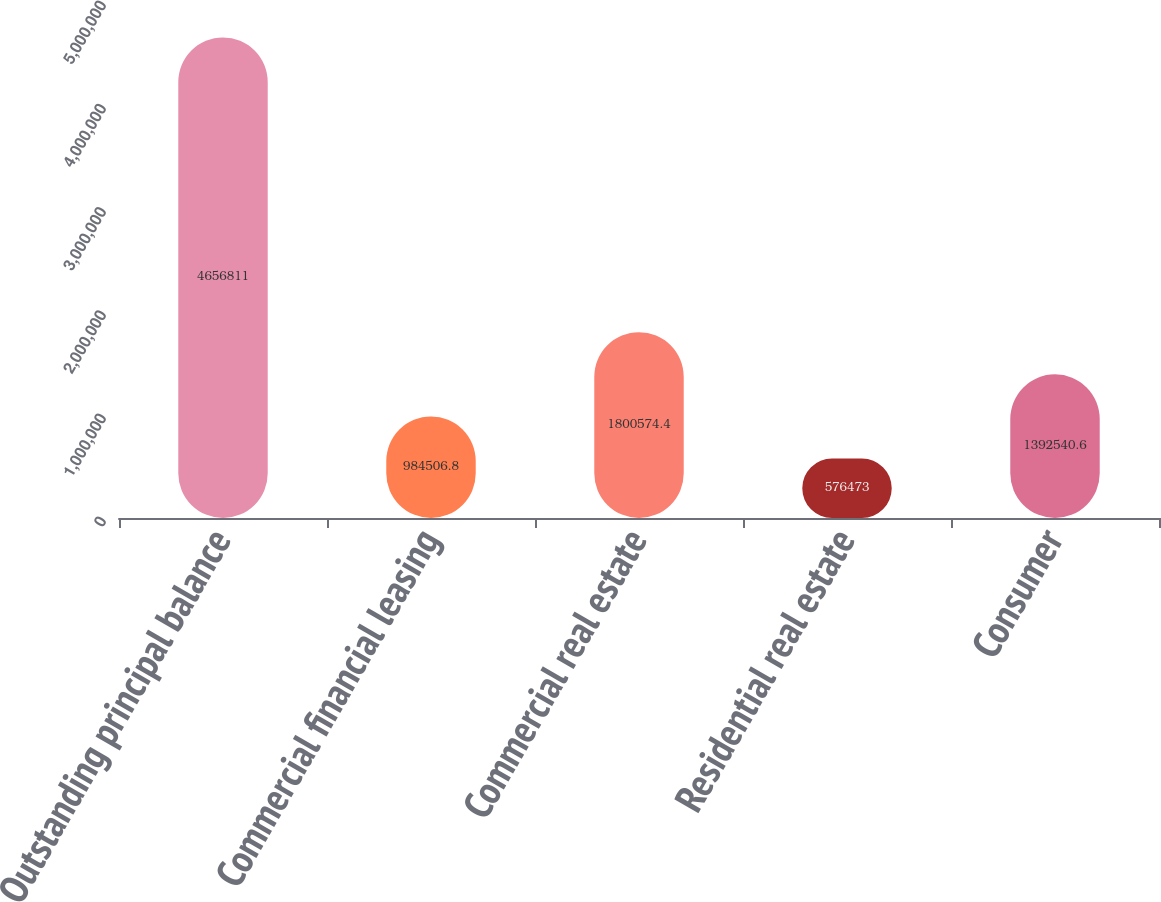Convert chart. <chart><loc_0><loc_0><loc_500><loc_500><bar_chart><fcel>Outstanding principal balance<fcel>Commercial financial leasing<fcel>Commercial real estate<fcel>Residential real estate<fcel>Consumer<nl><fcel>4.65681e+06<fcel>984507<fcel>1.80057e+06<fcel>576473<fcel>1.39254e+06<nl></chart> 